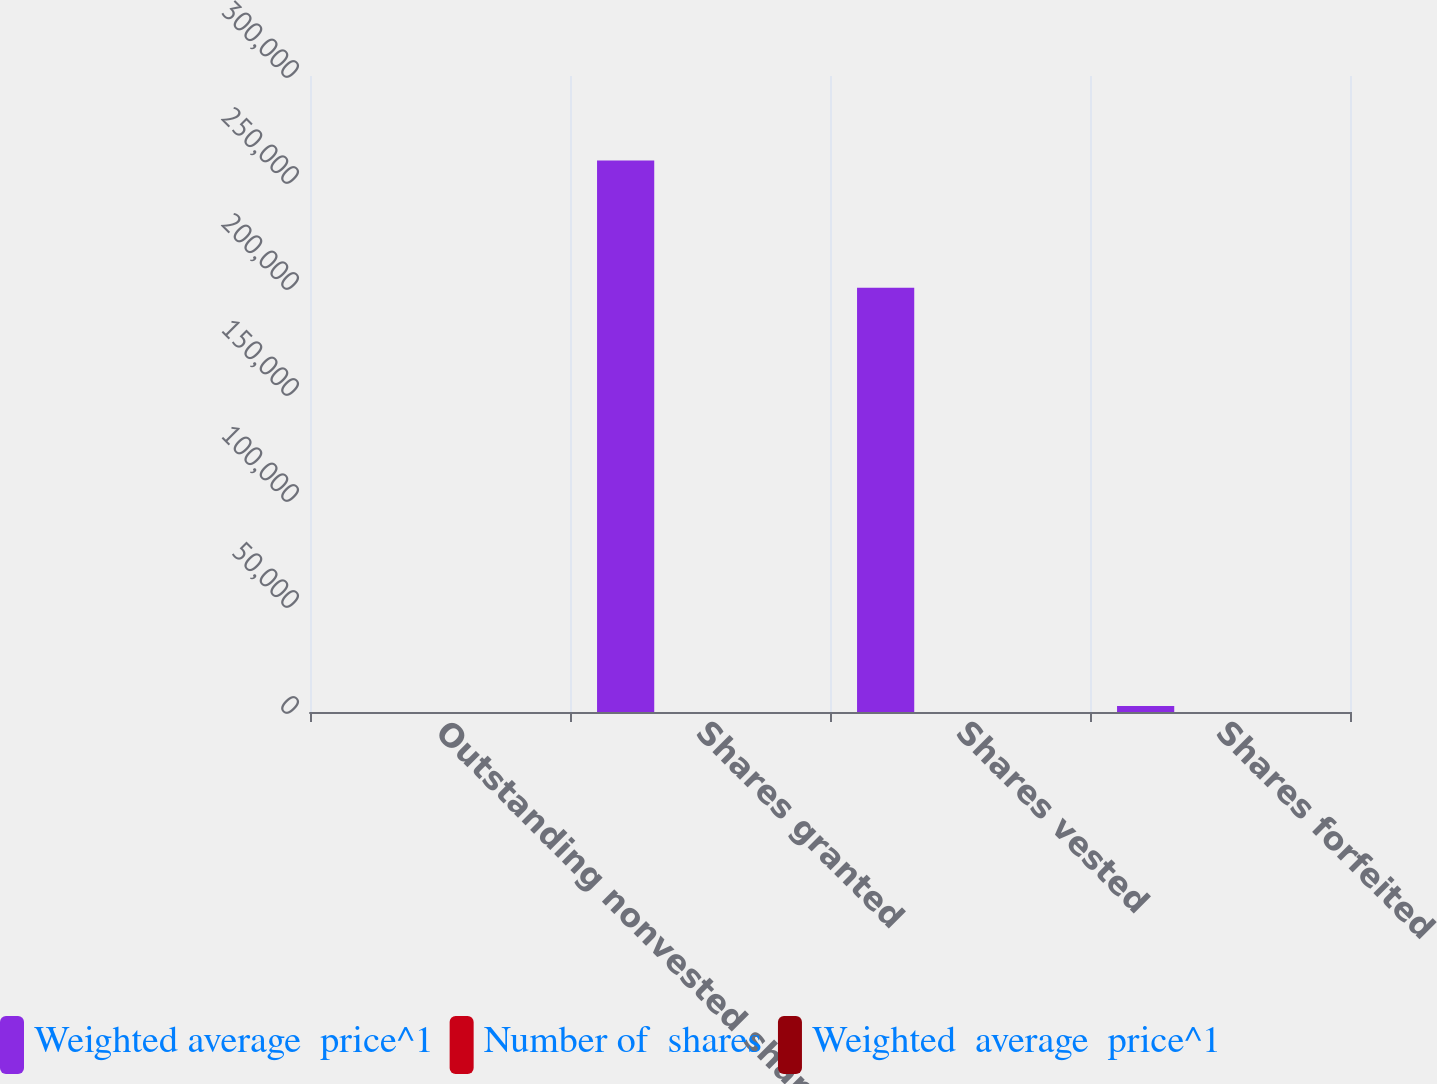<chart> <loc_0><loc_0><loc_500><loc_500><stacked_bar_chart><ecel><fcel>Outstanding nonvested shares<fcel>Shares granted<fcel>Shares vested<fcel>Shares forfeited<nl><fcel>Weighted average  price^1<fcel>48.15<fcel>260171<fcel>200066<fcel>2864<nl><fcel>Number of  shares<fcel>48.33<fcel>54.14<fcel>43.26<fcel>48.15<nl><fcel>Weighted  average  price^1<fcel>30.46<fcel>50.87<fcel>37.7<fcel>45.58<nl></chart> 